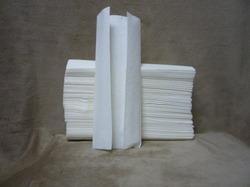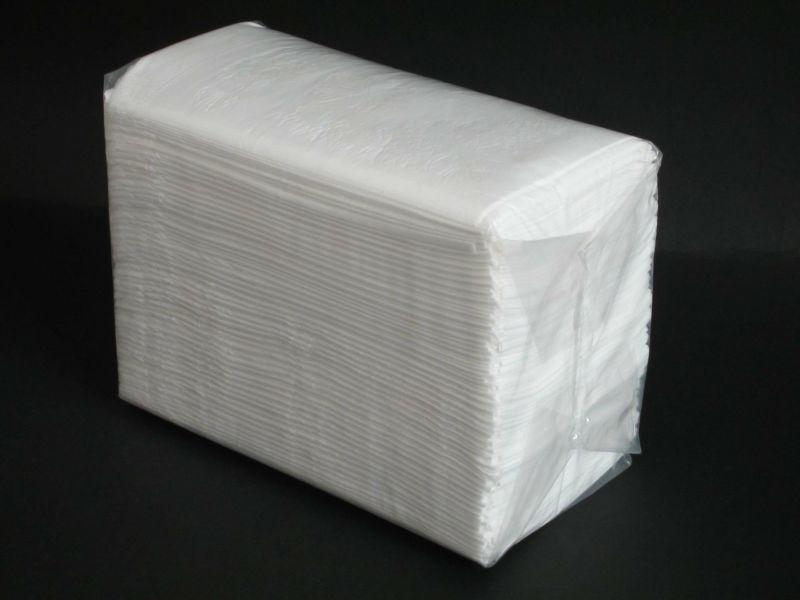The first image is the image on the left, the second image is the image on the right. For the images shown, is this caption "The right image contains one wrapped pack of folded paper towels, and the left image shows a single folded towel that is not aligned with a neat stack." true? Answer yes or no. Yes. 